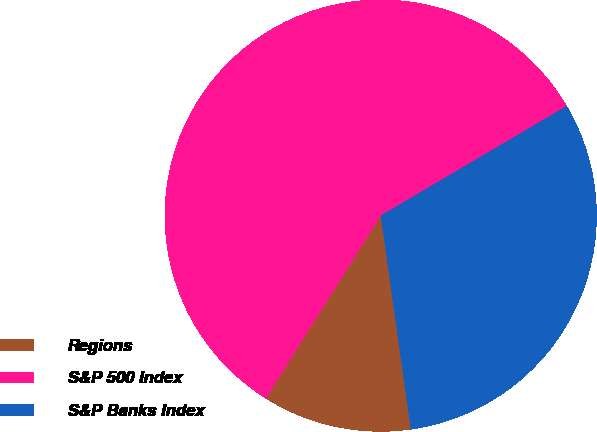Convert chart to OTSL. <chart><loc_0><loc_0><loc_500><loc_500><pie_chart><fcel>Regions<fcel>S&P 500 Index<fcel>S&P Banks Index<nl><fcel>11.15%<fcel>57.6%<fcel>31.25%<nl></chart> 